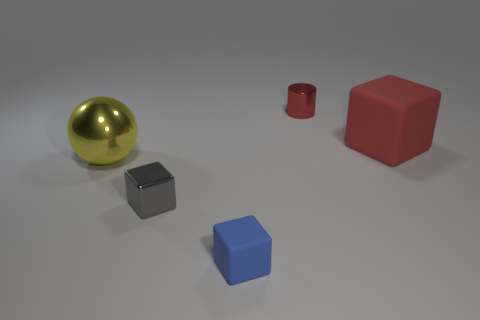Subtract all tiny gray metal blocks. How many blocks are left? 2 Add 4 big cyan cylinders. How many objects exist? 9 Subtract all yellow cubes. Subtract all gray cylinders. How many cubes are left? 3 Subtract all cubes. How many objects are left? 2 Subtract all gray objects. Subtract all yellow shiny spheres. How many objects are left? 3 Add 4 red rubber objects. How many red rubber objects are left? 5 Add 3 large yellow metal objects. How many large yellow metal objects exist? 4 Subtract 1 gray cubes. How many objects are left? 4 